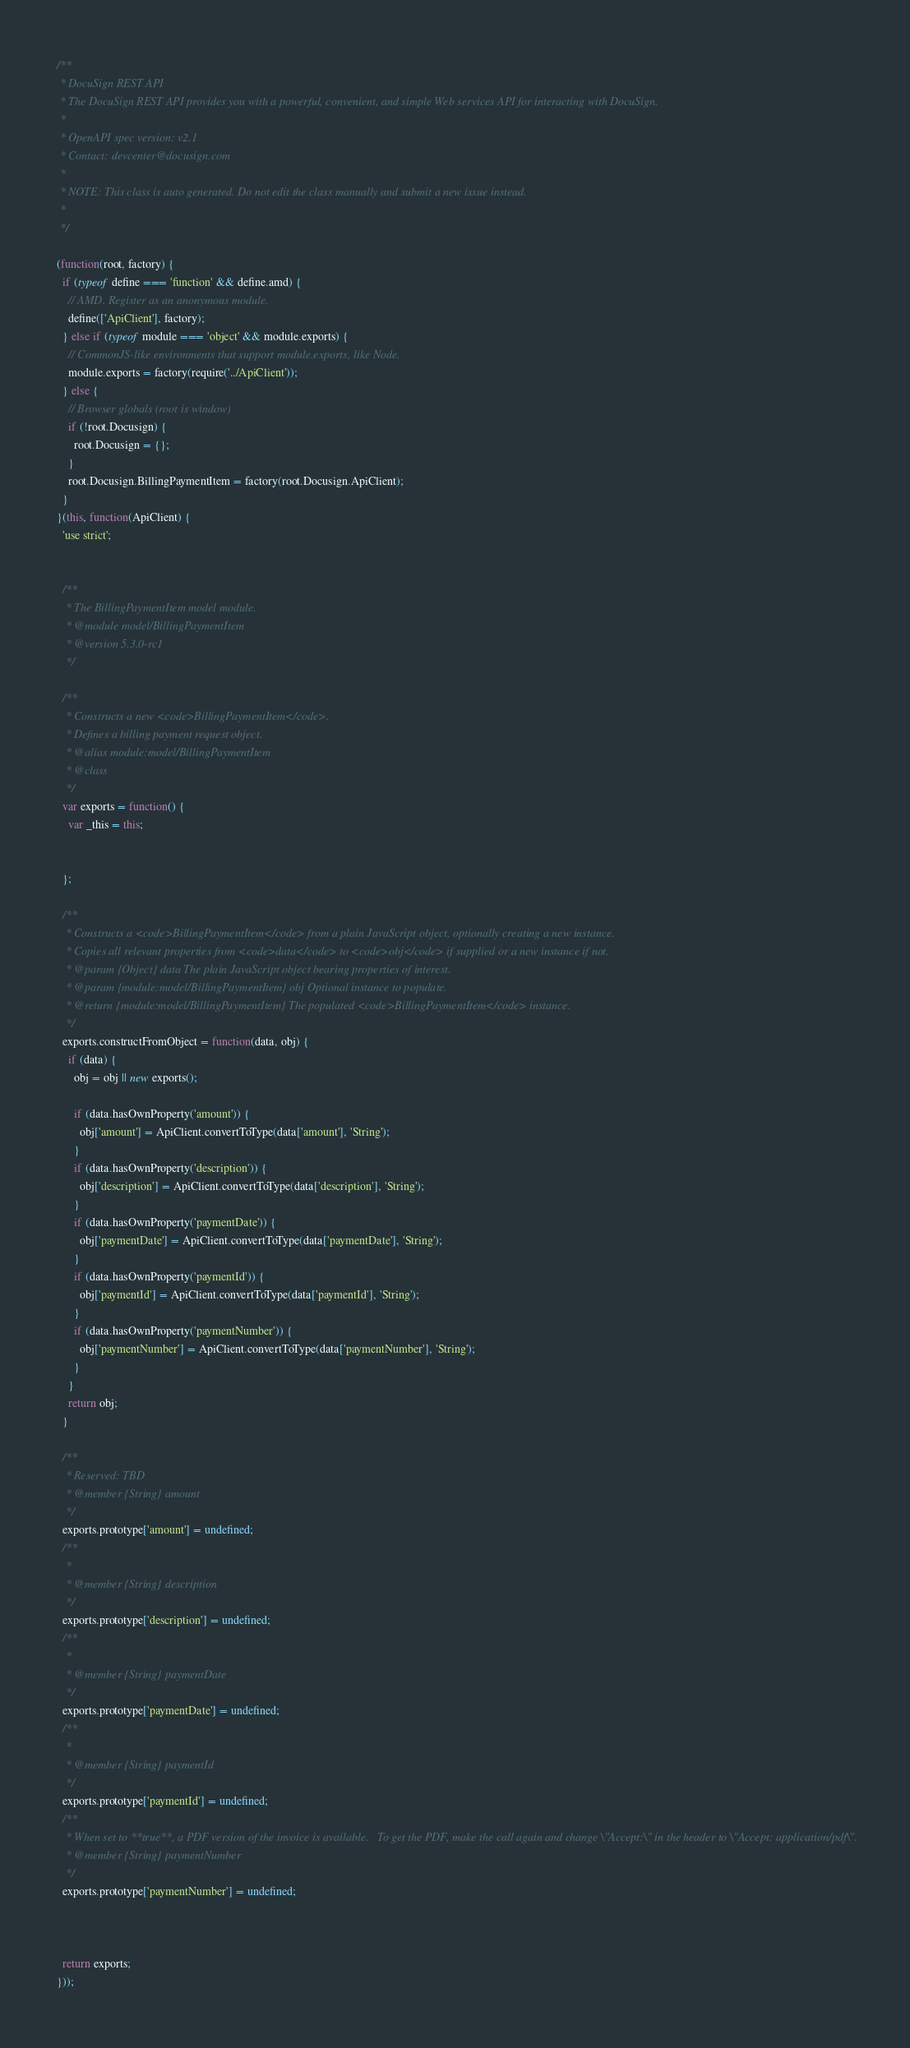<code> <loc_0><loc_0><loc_500><loc_500><_JavaScript_>/**
 * DocuSign REST API
 * The DocuSign REST API provides you with a powerful, convenient, and simple Web services API for interacting with DocuSign.
 *
 * OpenAPI spec version: v2.1
 * Contact: devcenter@docusign.com
 *
 * NOTE: This class is auto generated. Do not edit the class manually and submit a new issue instead.
 *
 */

(function(root, factory) {
  if (typeof define === 'function' && define.amd) {
    // AMD. Register as an anonymous module.
    define(['ApiClient'], factory);
  } else if (typeof module === 'object' && module.exports) {
    // CommonJS-like environments that support module.exports, like Node.
    module.exports = factory(require('../ApiClient'));
  } else {
    // Browser globals (root is window)
    if (!root.Docusign) {
      root.Docusign = {};
    }
    root.Docusign.BillingPaymentItem = factory(root.Docusign.ApiClient);
  }
}(this, function(ApiClient) {
  'use strict';


  /**
   * The BillingPaymentItem model module.
   * @module model/BillingPaymentItem
   * @version 5.3.0-rc1
   */

  /**
   * Constructs a new <code>BillingPaymentItem</code>.
   * Defines a billing payment request object.
   * @alias module:model/BillingPaymentItem
   * @class
   */
  var exports = function() {
    var _this = this;


  };

  /**
   * Constructs a <code>BillingPaymentItem</code> from a plain JavaScript object, optionally creating a new instance.
   * Copies all relevant properties from <code>data</code> to <code>obj</code> if supplied or a new instance if not.
   * @param {Object} data The plain JavaScript object bearing properties of interest.
   * @param {module:model/BillingPaymentItem} obj Optional instance to populate.
   * @return {module:model/BillingPaymentItem} The populated <code>BillingPaymentItem</code> instance.
   */
  exports.constructFromObject = function(data, obj) {
    if (data) {
      obj = obj || new exports();

      if (data.hasOwnProperty('amount')) {
        obj['amount'] = ApiClient.convertToType(data['amount'], 'String');
      }
      if (data.hasOwnProperty('description')) {
        obj['description'] = ApiClient.convertToType(data['description'], 'String');
      }
      if (data.hasOwnProperty('paymentDate')) {
        obj['paymentDate'] = ApiClient.convertToType(data['paymentDate'], 'String');
      }
      if (data.hasOwnProperty('paymentId')) {
        obj['paymentId'] = ApiClient.convertToType(data['paymentId'], 'String');
      }
      if (data.hasOwnProperty('paymentNumber')) {
        obj['paymentNumber'] = ApiClient.convertToType(data['paymentNumber'], 'String');
      }
    }
    return obj;
  }

  /**
   * Reserved: TBD
   * @member {String} amount
   */
  exports.prototype['amount'] = undefined;
  /**
   * 
   * @member {String} description
   */
  exports.prototype['description'] = undefined;
  /**
   * 
   * @member {String} paymentDate
   */
  exports.prototype['paymentDate'] = undefined;
  /**
   * 
   * @member {String} paymentId
   */
  exports.prototype['paymentId'] = undefined;
  /**
   * When set to **true**, a PDF version of the invoice is available.   To get the PDF, make the call again and change \"Accept:\" in the header to \"Accept: application/pdf\".
   * @member {String} paymentNumber
   */
  exports.prototype['paymentNumber'] = undefined;



  return exports;
}));


</code> 